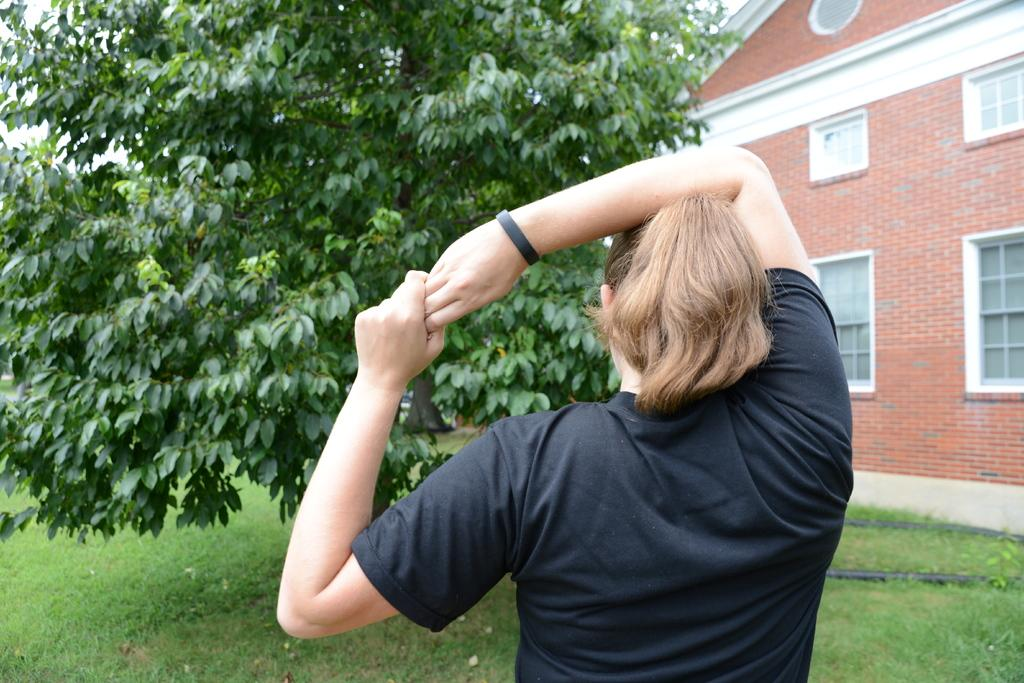What type of structure is in the picture? There is a house in the picture. What features can be seen on the house? The house has windows. What natural elements are present in the picture? There is a tree and grass in the picture. Who is in the picture? There is a woman in the picture. What is the woman wearing on her wrist? The woman is wearing a black wrist band. What type of clothing is the woman wearing on her upper body? The woman is wearing a t-shirt. Can you tell me how many airplanes are flying over the house in the picture? There is no airplane visible in the picture; it only shows a house, a tree, grass, and a woman. What type of apparel is the tree wearing in the picture? Trees do not wear apparel, as they are plants and not people. 